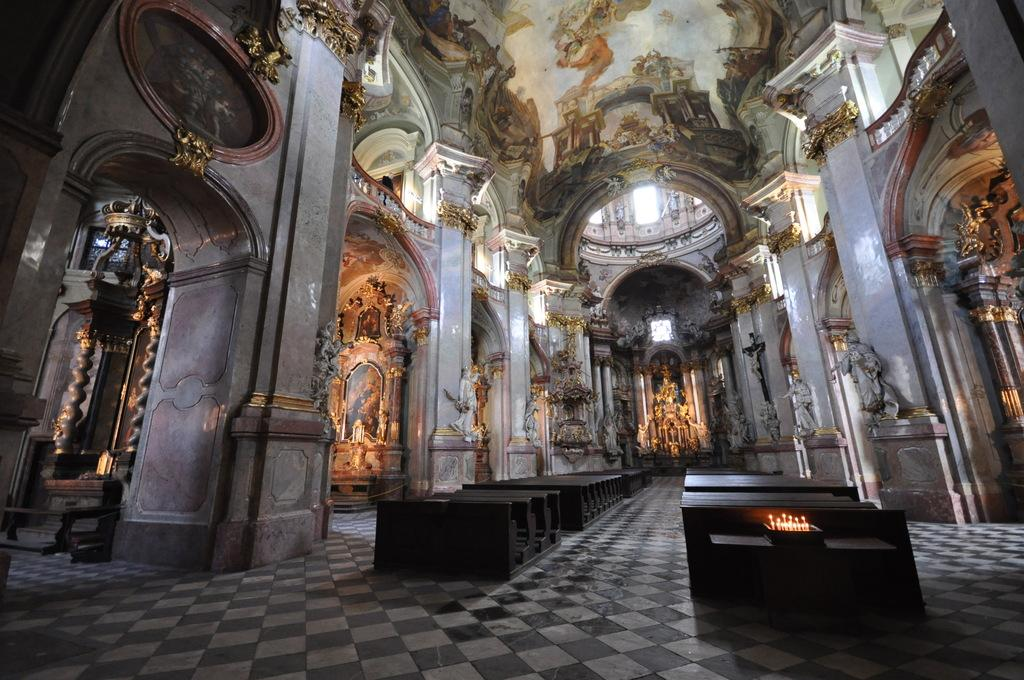Where is the setting of the image? The image is inside a building. What objects can be seen providing light in the image? There are candles in the image. What type of furniture is present in the image? There are wooden tables in the image. How many eyes can be seen on the snail in the image? There is no snail present in the image, so it is not possible to determine the number of eyes on a snail. 